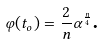<formula> <loc_0><loc_0><loc_500><loc_500>\varphi ( t _ { o } ) = \frac { 2 } { n } \alpha ^ { \frac { n } { 4 } } \text {.}</formula> 